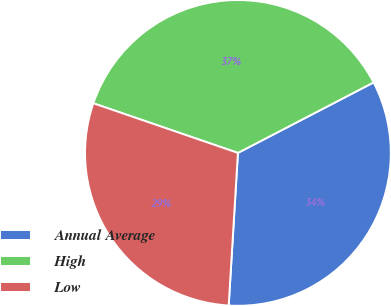<chart> <loc_0><loc_0><loc_500><loc_500><pie_chart><fcel>Annual Average<fcel>High<fcel>Low<nl><fcel>33.59%<fcel>37.11%<fcel>29.3%<nl></chart> 